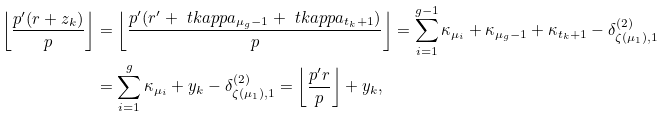Convert formula to latex. <formula><loc_0><loc_0><loc_500><loc_500>\left \lfloor \frac { p ^ { \prime } ( r + z _ { k } ) } { p } \right \rfloor & = \left \lfloor \frac { p ^ { \prime } ( r ^ { \prime } + \ t k a p p a _ { \mu _ { g } - 1 } + \ t k a p p a _ { t _ { k } + 1 } ) } { p } \right \rfloor = \sum _ { i = 1 } ^ { g - 1 } \kappa _ { \mu _ { i } } + \kappa _ { \mu _ { g } - 1 } + \kappa _ { t _ { k } + 1 } - \delta ^ { ( 2 ) } _ { \zeta ( \mu _ { 1 } ) , 1 } \\ & = \sum _ { i = 1 } ^ { g } \kappa _ { \mu _ { i } } + y _ { k } - \delta ^ { ( 2 ) } _ { \zeta ( \mu _ { 1 } ) , 1 } = \left \lfloor \frac { p ^ { \prime } r } { p } \right \rfloor + y _ { k } ,</formula> 